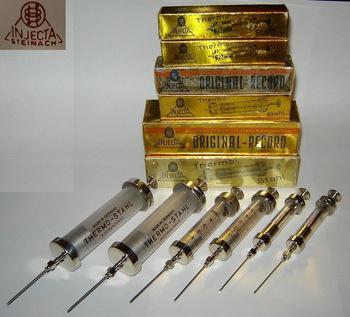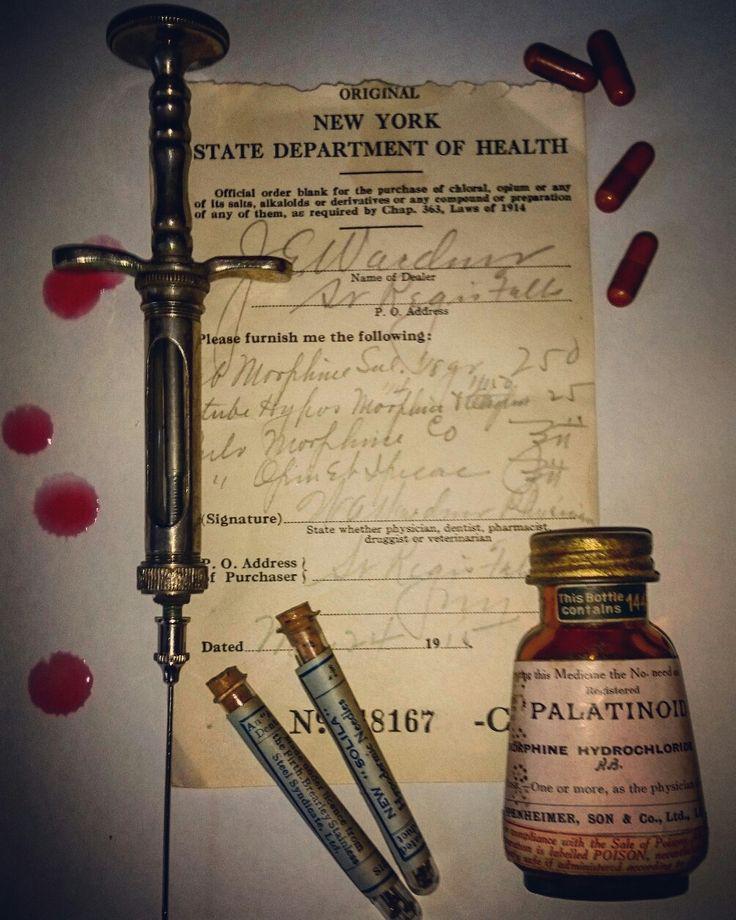The first image is the image on the left, the second image is the image on the right. Evaluate the accuracy of this statement regarding the images: "Syringes sit in front of yellow boxes in one of the images.". Is it true? Answer yes or no. Yes. The first image is the image on the left, the second image is the image on the right. Assess this claim about the two images: "An image shows one open rectangular metal case with syringe items inside of it.". Correct or not? Answer yes or no. No. 